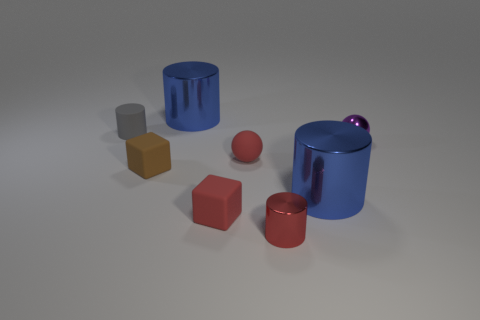Subtract all red cylinders. How many cylinders are left? 3 Subtract all cyan cylinders. Subtract all brown spheres. How many cylinders are left? 4 Subtract all balls. How many objects are left? 6 Add 1 small metallic cylinders. How many objects exist? 9 Add 8 cyan metal blocks. How many cyan metal blocks exist? 8 Subtract 0 blue spheres. How many objects are left? 8 Subtract all large red rubber balls. Subtract all purple metal objects. How many objects are left? 7 Add 8 rubber cubes. How many rubber cubes are left? 10 